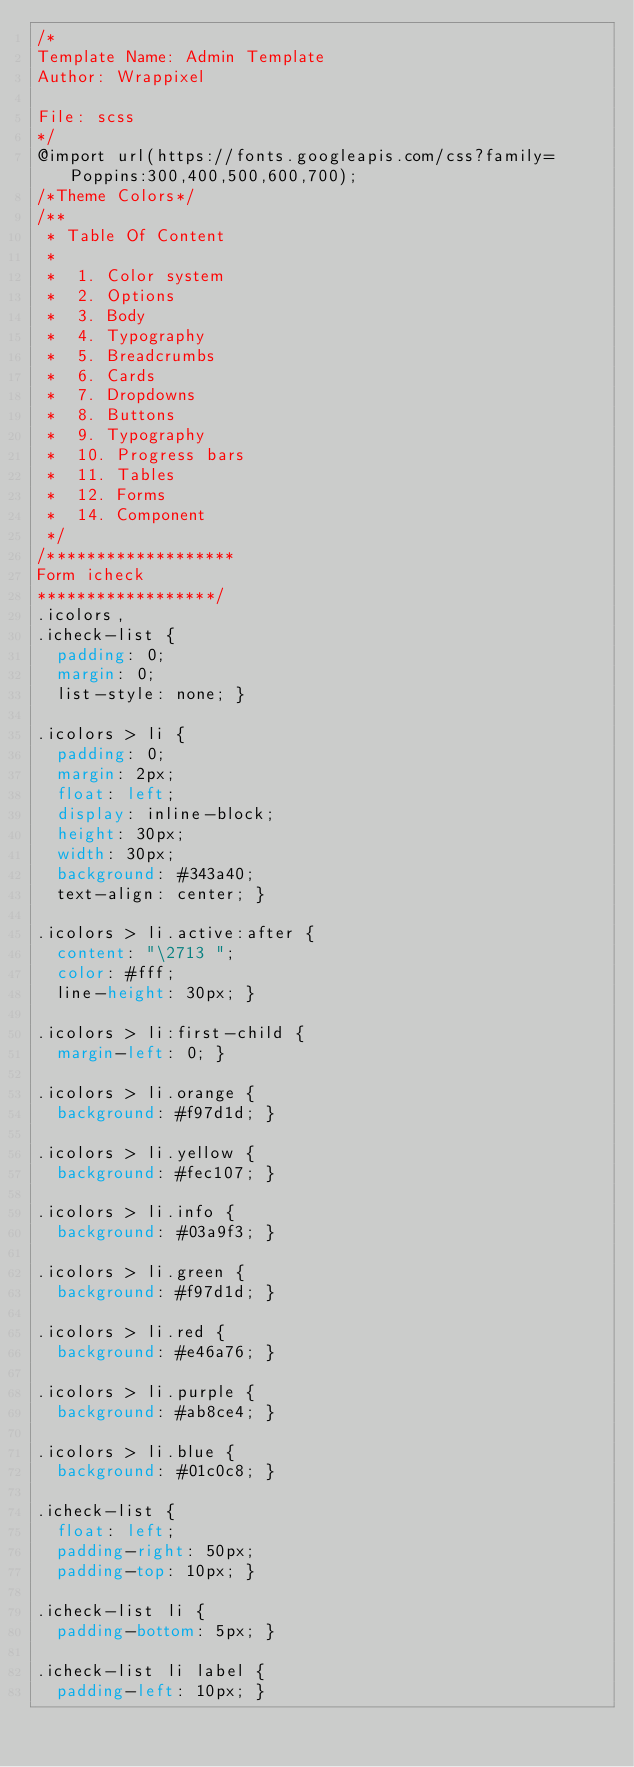Convert code to text. <code><loc_0><loc_0><loc_500><loc_500><_CSS_>/*
Template Name: Admin Template
Author: Wrappixel

File: scss
*/
@import url(https://fonts.googleapis.com/css?family=Poppins:300,400,500,600,700);
/*Theme Colors*/
/**
 * Table Of Content
 *
 * 	1. Color system
 *	2. Options
 *	3. Body
 *	4. Typography
 *	5. Breadcrumbs
 *	6. Cards
 *	7. Dropdowns
 *	8. Buttons
 *	9. Typography
 *	10. Progress bars
 *	11. Tables
 *	12. Forms
 *	14. Component
 */
/*******************
Form icheck
******************/
.icolors,
.icheck-list {
  padding: 0;
  margin: 0;
  list-style: none; }

.icolors > li {
  padding: 0;
  margin: 2px;
  float: left;
  display: inline-block;
  height: 30px;
  width: 30px;
  background: #343a40;
  text-align: center; }

.icolors > li.active:after {
  content: "\2713 ";
  color: #fff;
  line-height: 30px; }

.icolors > li:first-child {
  margin-left: 0; }

.icolors > li.orange {
  background: #f97d1d; }

.icolors > li.yellow {
  background: #fec107; }

.icolors > li.info {
  background: #03a9f3; }

.icolors > li.green {
  background: #f97d1d; }

.icolors > li.red {
  background: #e46a76; }

.icolors > li.purple {
  background: #ab8ce4; }

.icolors > li.blue {
  background: #01c0c8; }

.icheck-list {
  float: left;
  padding-right: 50px;
  padding-top: 10px; }

.icheck-list li {
  padding-bottom: 5px; }

.icheck-list li label {
  padding-left: 10px; }
</code> 